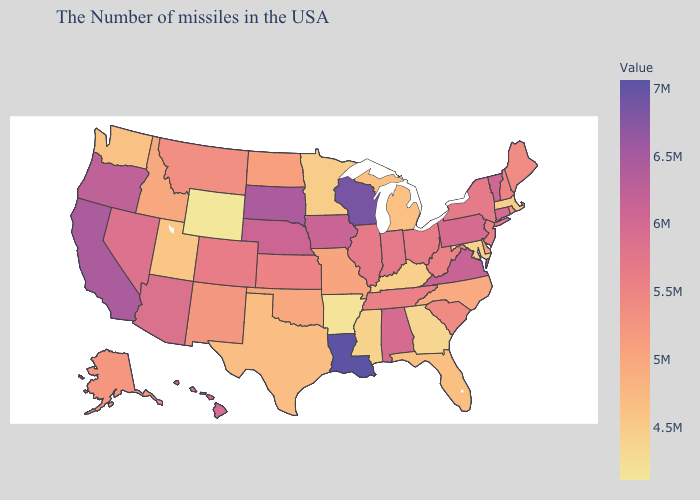Which states have the lowest value in the USA?
Short answer required. Wyoming. Among the states that border Washington , does Oregon have the highest value?
Answer briefly. Yes. Does Hawaii have a higher value than Oregon?
Be succinct. No. Is the legend a continuous bar?
Keep it brief. Yes. Is the legend a continuous bar?
Keep it brief. Yes. 